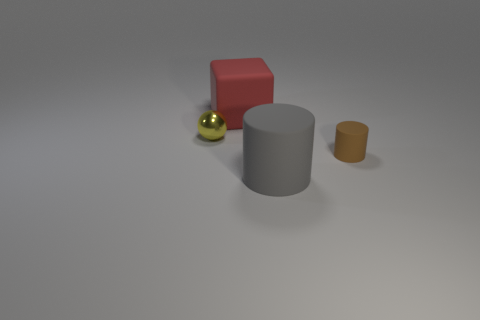Add 3 spheres. How many objects exist? 7 Subtract all large red matte objects. Subtract all shiny balls. How many objects are left? 2 Add 3 small brown matte things. How many small brown matte things are left? 4 Add 3 tiny metallic spheres. How many tiny metallic spheres exist? 4 Subtract 0 cyan spheres. How many objects are left? 4 Subtract all cubes. How many objects are left? 3 Subtract all green blocks. Subtract all green balls. How many blocks are left? 1 